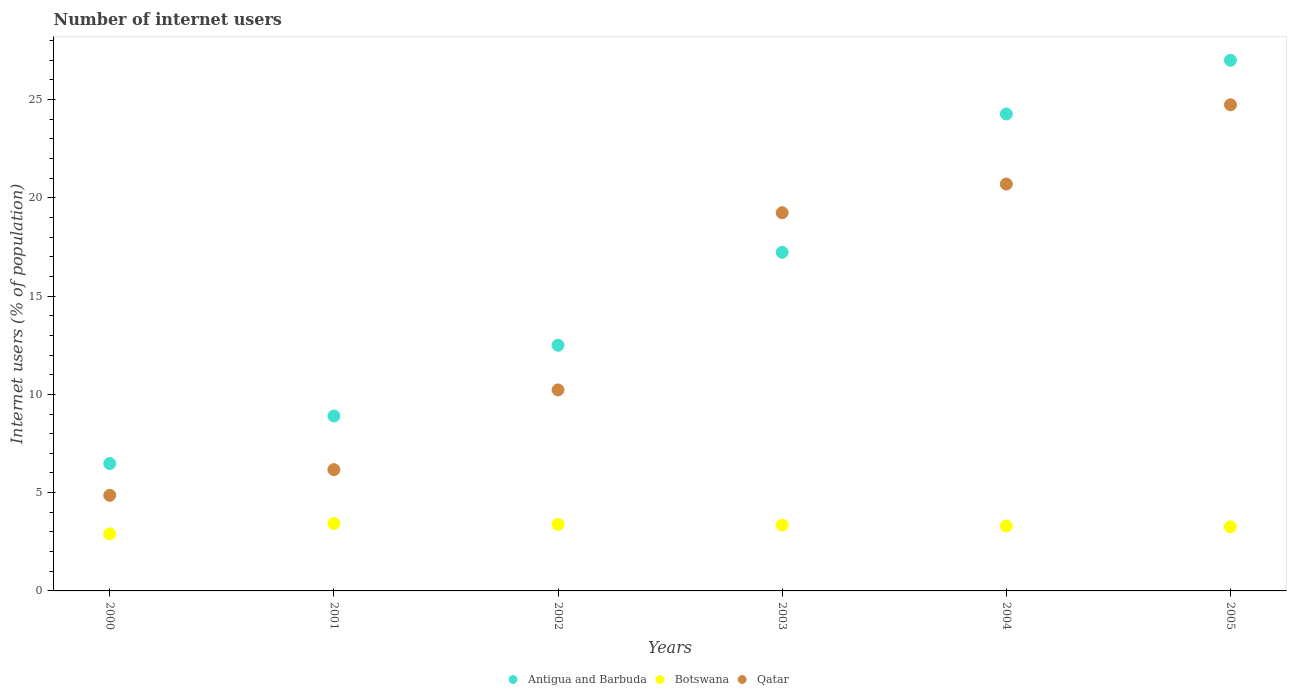How many different coloured dotlines are there?
Make the answer very short. 3. Is the number of dotlines equal to the number of legend labels?
Provide a succinct answer. Yes. What is the number of internet users in Botswana in 2005?
Offer a very short reply. 3.26. Across all years, what is the maximum number of internet users in Botswana?
Offer a very short reply. 3.43. Across all years, what is the minimum number of internet users in Qatar?
Your response must be concise. 4.86. What is the total number of internet users in Antigua and Barbuda in the graph?
Keep it short and to the point. 96.38. What is the difference between the number of internet users in Botswana in 2002 and that in 2004?
Your answer should be very brief. 0.08. What is the difference between the number of internet users in Botswana in 2002 and the number of internet users in Antigua and Barbuda in 2000?
Ensure brevity in your answer.  -3.1. What is the average number of internet users in Qatar per year?
Offer a very short reply. 14.32. In the year 2004, what is the difference between the number of internet users in Botswana and number of internet users in Antigua and Barbuda?
Ensure brevity in your answer.  -20.96. What is the ratio of the number of internet users in Botswana in 2002 to that in 2005?
Provide a succinct answer. 1.04. Is the number of internet users in Botswana in 2000 less than that in 2005?
Offer a very short reply. Yes. What is the difference between the highest and the second highest number of internet users in Antigua and Barbuda?
Your answer should be very brief. 2.73. What is the difference between the highest and the lowest number of internet users in Botswana?
Provide a succinct answer. 0.53. Is the sum of the number of internet users in Botswana in 2004 and 2005 greater than the maximum number of internet users in Antigua and Barbuda across all years?
Give a very brief answer. No. Does the number of internet users in Qatar monotonically increase over the years?
Provide a succinct answer. Yes. Is the number of internet users in Antigua and Barbuda strictly greater than the number of internet users in Botswana over the years?
Your answer should be very brief. Yes. Is the number of internet users in Antigua and Barbuda strictly less than the number of internet users in Botswana over the years?
Keep it short and to the point. No. What is the difference between two consecutive major ticks on the Y-axis?
Your answer should be compact. 5. Are the values on the major ticks of Y-axis written in scientific E-notation?
Your response must be concise. No. Does the graph contain any zero values?
Your answer should be compact. No. Where does the legend appear in the graph?
Offer a very short reply. Bottom center. How many legend labels are there?
Keep it short and to the point. 3. How are the legend labels stacked?
Ensure brevity in your answer.  Horizontal. What is the title of the graph?
Keep it short and to the point. Number of internet users. What is the label or title of the X-axis?
Give a very brief answer. Years. What is the label or title of the Y-axis?
Your answer should be very brief. Internet users (% of population). What is the Internet users (% of population) of Antigua and Barbuda in 2000?
Give a very brief answer. 6.48. What is the Internet users (% of population) of Botswana in 2000?
Offer a very short reply. 2.9. What is the Internet users (% of population) in Qatar in 2000?
Offer a terse response. 4.86. What is the Internet users (% of population) in Antigua and Barbuda in 2001?
Your answer should be very brief. 8.9. What is the Internet users (% of population) of Botswana in 2001?
Provide a short and direct response. 3.43. What is the Internet users (% of population) in Qatar in 2001?
Ensure brevity in your answer.  6.17. What is the Internet users (% of population) in Botswana in 2002?
Provide a succinct answer. 3.39. What is the Internet users (% of population) in Qatar in 2002?
Offer a terse response. 10.23. What is the Internet users (% of population) in Antigua and Barbuda in 2003?
Provide a short and direct response. 17.23. What is the Internet users (% of population) in Botswana in 2003?
Give a very brief answer. 3.35. What is the Internet users (% of population) of Qatar in 2003?
Make the answer very short. 19.24. What is the Internet users (% of population) of Antigua and Barbuda in 2004?
Provide a short and direct response. 24.27. What is the Internet users (% of population) of Botswana in 2004?
Provide a short and direct response. 3.3. What is the Internet users (% of population) in Qatar in 2004?
Your answer should be compact. 20.7. What is the Internet users (% of population) of Botswana in 2005?
Provide a short and direct response. 3.26. What is the Internet users (% of population) in Qatar in 2005?
Your answer should be compact. 24.73. Across all years, what is the maximum Internet users (% of population) of Botswana?
Your answer should be very brief. 3.43. Across all years, what is the maximum Internet users (% of population) in Qatar?
Your answer should be compact. 24.73. Across all years, what is the minimum Internet users (% of population) in Antigua and Barbuda?
Keep it short and to the point. 6.48. Across all years, what is the minimum Internet users (% of population) of Botswana?
Ensure brevity in your answer.  2.9. Across all years, what is the minimum Internet users (% of population) in Qatar?
Offer a very short reply. 4.86. What is the total Internet users (% of population) in Antigua and Barbuda in the graph?
Your response must be concise. 96.38. What is the total Internet users (% of population) of Botswana in the graph?
Offer a very short reply. 19.63. What is the total Internet users (% of population) in Qatar in the graph?
Your answer should be very brief. 85.94. What is the difference between the Internet users (% of population) in Antigua and Barbuda in 2000 and that in 2001?
Your answer should be compact. -2.42. What is the difference between the Internet users (% of population) of Botswana in 2000 and that in 2001?
Keep it short and to the point. -0.53. What is the difference between the Internet users (% of population) of Qatar in 2000 and that in 2001?
Provide a succinct answer. -1.31. What is the difference between the Internet users (% of population) in Antigua and Barbuda in 2000 and that in 2002?
Provide a short and direct response. -6.02. What is the difference between the Internet users (% of population) in Botswana in 2000 and that in 2002?
Your answer should be very brief. -0.48. What is the difference between the Internet users (% of population) of Qatar in 2000 and that in 2002?
Provide a succinct answer. -5.36. What is the difference between the Internet users (% of population) of Antigua and Barbuda in 2000 and that in 2003?
Make the answer very short. -10.75. What is the difference between the Internet users (% of population) of Botswana in 2000 and that in 2003?
Offer a very short reply. -0.44. What is the difference between the Internet users (% of population) of Qatar in 2000 and that in 2003?
Make the answer very short. -14.38. What is the difference between the Internet users (% of population) in Antigua and Barbuda in 2000 and that in 2004?
Make the answer very short. -17.78. What is the difference between the Internet users (% of population) in Botswana in 2000 and that in 2004?
Provide a short and direct response. -0.4. What is the difference between the Internet users (% of population) of Qatar in 2000 and that in 2004?
Your response must be concise. -15.84. What is the difference between the Internet users (% of population) in Antigua and Barbuda in 2000 and that in 2005?
Your answer should be compact. -20.52. What is the difference between the Internet users (% of population) of Botswana in 2000 and that in 2005?
Offer a very short reply. -0.36. What is the difference between the Internet users (% of population) in Qatar in 2000 and that in 2005?
Keep it short and to the point. -19.87. What is the difference between the Internet users (% of population) of Antigua and Barbuda in 2001 and that in 2002?
Provide a short and direct response. -3.6. What is the difference between the Internet users (% of population) of Botswana in 2001 and that in 2002?
Your answer should be very brief. 0.04. What is the difference between the Internet users (% of population) of Qatar in 2001 and that in 2002?
Make the answer very short. -4.06. What is the difference between the Internet users (% of population) in Antigua and Barbuda in 2001 and that in 2003?
Provide a succinct answer. -8.33. What is the difference between the Internet users (% of population) in Botswana in 2001 and that in 2003?
Provide a succinct answer. 0.09. What is the difference between the Internet users (% of population) of Qatar in 2001 and that in 2003?
Provide a succinct answer. -13.07. What is the difference between the Internet users (% of population) in Antigua and Barbuda in 2001 and that in 2004?
Provide a short and direct response. -15.37. What is the difference between the Internet users (% of population) in Botswana in 2001 and that in 2004?
Your answer should be compact. 0.13. What is the difference between the Internet users (% of population) in Qatar in 2001 and that in 2004?
Offer a terse response. -14.53. What is the difference between the Internet users (% of population) of Antigua and Barbuda in 2001 and that in 2005?
Your answer should be compact. -18.1. What is the difference between the Internet users (% of population) in Botswana in 2001 and that in 2005?
Provide a succinct answer. 0.17. What is the difference between the Internet users (% of population) in Qatar in 2001 and that in 2005?
Your response must be concise. -18.56. What is the difference between the Internet users (% of population) of Antigua and Barbuda in 2002 and that in 2003?
Your answer should be compact. -4.73. What is the difference between the Internet users (% of population) in Botswana in 2002 and that in 2003?
Your answer should be very brief. 0.04. What is the difference between the Internet users (% of population) of Qatar in 2002 and that in 2003?
Ensure brevity in your answer.  -9.02. What is the difference between the Internet users (% of population) of Antigua and Barbuda in 2002 and that in 2004?
Offer a very short reply. -11.77. What is the difference between the Internet users (% of population) in Botswana in 2002 and that in 2004?
Give a very brief answer. 0.08. What is the difference between the Internet users (% of population) in Qatar in 2002 and that in 2004?
Your answer should be very brief. -10.48. What is the difference between the Internet users (% of population) in Antigua and Barbuda in 2002 and that in 2005?
Your response must be concise. -14.5. What is the difference between the Internet users (% of population) of Botswana in 2002 and that in 2005?
Give a very brief answer. 0.12. What is the difference between the Internet users (% of population) of Qatar in 2002 and that in 2005?
Your answer should be very brief. -14.51. What is the difference between the Internet users (% of population) in Antigua and Barbuda in 2003 and that in 2004?
Provide a short and direct response. -7.04. What is the difference between the Internet users (% of population) in Botswana in 2003 and that in 2004?
Provide a succinct answer. 0.04. What is the difference between the Internet users (% of population) in Qatar in 2003 and that in 2004?
Your answer should be very brief. -1.46. What is the difference between the Internet users (% of population) of Antigua and Barbuda in 2003 and that in 2005?
Give a very brief answer. -9.77. What is the difference between the Internet users (% of population) of Botswana in 2003 and that in 2005?
Your answer should be very brief. 0.08. What is the difference between the Internet users (% of population) of Qatar in 2003 and that in 2005?
Give a very brief answer. -5.49. What is the difference between the Internet users (% of population) in Antigua and Barbuda in 2004 and that in 2005?
Your answer should be very brief. -2.73. What is the difference between the Internet users (% of population) of Botswana in 2004 and that in 2005?
Make the answer very short. 0.04. What is the difference between the Internet users (% of population) of Qatar in 2004 and that in 2005?
Give a very brief answer. -4.03. What is the difference between the Internet users (% of population) in Antigua and Barbuda in 2000 and the Internet users (% of population) in Botswana in 2001?
Your answer should be compact. 3.05. What is the difference between the Internet users (% of population) in Antigua and Barbuda in 2000 and the Internet users (% of population) in Qatar in 2001?
Your response must be concise. 0.31. What is the difference between the Internet users (% of population) in Botswana in 2000 and the Internet users (% of population) in Qatar in 2001?
Keep it short and to the point. -3.27. What is the difference between the Internet users (% of population) of Antigua and Barbuda in 2000 and the Internet users (% of population) of Botswana in 2002?
Your response must be concise. 3.1. What is the difference between the Internet users (% of population) in Antigua and Barbuda in 2000 and the Internet users (% of population) in Qatar in 2002?
Offer a very short reply. -3.74. What is the difference between the Internet users (% of population) of Botswana in 2000 and the Internet users (% of population) of Qatar in 2002?
Provide a short and direct response. -7.32. What is the difference between the Internet users (% of population) in Antigua and Barbuda in 2000 and the Internet users (% of population) in Botswana in 2003?
Your answer should be compact. 3.14. What is the difference between the Internet users (% of population) in Antigua and Barbuda in 2000 and the Internet users (% of population) in Qatar in 2003?
Keep it short and to the point. -12.76. What is the difference between the Internet users (% of population) in Botswana in 2000 and the Internet users (% of population) in Qatar in 2003?
Make the answer very short. -16.34. What is the difference between the Internet users (% of population) in Antigua and Barbuda in 2000 and the Internet users (% of population) in Botswana in 2004?
Offer a terse response. 3.18. What is the difference between the Internet users (% of population) in Antigua and Barbuda in 2000 and the Internet users (% of population) in Qatar in 2004?
Offer a terse response. -14.22. What is the difference between the Internet users (% of population) of Botswana in 2000 and the Internet users (% of population) of Qatar in 2004?
Provide a short and direct response. -17.8. What is the difference between the Internet users (% of population) of Antigua and Barbuda in 2000 and the Internet users (% of population) of Botswana in 2005?
Ensure brevity in your answer.  3.22. What is the difference between the Internet users (% of population) in Antigua and Barbuda in 2000 and the Internet users (% of population) in Qatar in 2005?
Provide a short and direct response. -18.25. What is the difference between the Internet users (% of population) in Botswana in 2000 and the Internet users (% of population) in Qatar in 2005?
Your answer should be compact. -21.83. What is the difference between the Internet users (% of population) in Antigua and Barbuda in 2001 and the Internet users (% of population) in Botswana in 2002?
Keep it short and to the point. 5.51. What is the difference between the Internet users (% of population) of Antigua and Barbuda in 2001 and the Internet users (% of population) of Qatar in 2002?
Give a very brief answer. -1.33. What is the difference between the Internet users (% of population) of Botswana in 2001 and the Internet users (% of population) of Qatar in 2002?
Provide a short and direct response. -6.8. What is the difference between the Internet users (% of population) of Antigua and Barbuda in 2001 and the Internet users (% of population) of Botswana in 2003?
Give a very brief answer. 5.55. What is the difference between the Internet users (% of population) of Antigua and Barbuda in 2001 and the Internet users (% of population) of Qatar in 2003?
Your answer should be compact. -10.34. What is the difference between the Internet users (% of population) of Botswana in 2001 and the Internet users (% of population) of Qatar in 2003?
Offer a terse response. -15.81. What is the difference between the Internet users (% of population) in Antigua and Barbuda in 2001 and the Internet users (% of population) in Botswana in 2004?
Your answer should be very brief. 5.59. What is the difference between the Internet users (% of population) of Antigua and Barbuda in 2001 and the Internet users (% of population) of Qatar in 2004?
Your answer should be compact. -11.8. What is the difference between the Internet users (% of population) of Botswana in 2001 and the Internet users (% of population) of Qatar in 2004?
Give a very brief answer. -17.27. What is the difference between the Internet users (% of population) in Antigua and Barbuda in 2001 and the Internet users (% of population) in Botswana in 2005?
Provide a succinct answer. 5.64. What is the difference between the Internet users (% of population) of Antigua and Barbuda in 2001 and the Internet users (% of population) of Qatar in 2005?
Your response must be concise. -15.83. What is the difference between the Internet users (% of population) of Botswana in 2001 and the Internet users (% of population) of Qatar in 2005?
Keep it short and to the point. -21.3. What is the difference between the Internet users (% of population) of Antigua and Barbuda in 2002 and the Internet users (% of population) of Botswana in 2003?
Your response must be concise. 9.15. What is the difference between the Internet users (% of population) in Antigua and Barbuda in 2002 and the Internet users (% of population) in Qatar in 2003?
Give a very brief answer. -6.74. What is the difference between the Internet users (% of population) in Botswana in 2002 and the Internet users (% of population) in Qatar in 2003?
Your answer should be compact. -15.86. What is the difference between the Internet users (% of population) in Antigua and Barbuda in 2002 and the Internet users (% of population) in Botswana in 2004?
Give a very brief answer. 9.2. What is the difference between the Internet users (% of population) of Antigua and Barbuda in 2002 and the Internet users (% of population) of Qatar in 2004?
Offer a terse response. -8.2. What is the difference between the Internet users (% of population) in Botswana in 2002 and the Internet users (% of population) in Qatar in 2004?
Provide a short and direct response. -17.32. What is the difference between the Internet users (% of population) of Antigua and Barbuda in 2002 and the Internet users (% of population) of Botswana in 2005?
Keep it short and to the point. 9.24. What is the difference between the Internet users (% of population) in Antigua and Barbuda in 2002 and the Internet users (% of population) in Qatar in 2005?
Make the answer very short. -12.23. What is the difference between the Internet users (% of population) in Botswana in 2002 and the Internet users (% of population) in Qatar in 2005?
Offer a very short reply. -21.35. What is the difference between the Internet users (% of population) in Antigua and Barbuda in 2003 and the Internet users (% of population) in Botswana in 2004?
Keep it short and to the point. 13.92. What is the difference between the Internet users (% of population) in Antigua and Barbuda in 2003 and the Internet users (% of population) in Qatar in 2004?
Give a very brief answer. -3.47. What is the difference between the Internet users (% of population) of Botswana in 2003 and the Internet users (% of population) of Qatar in 2004?
Provide a succinct answer. -17.36. What is the difference between the Internet users (% of population) of Antigua and Barbuda in 2003 and the Internet users (% of population) of Botswana in 2005?
Make the answer very short. 13.97. What is the difference between the Internet users (% of population) of Antigua and Barbuda in 2003 and the Internet users (% of population) of Qatar in 2005?
Provide a succinct answer. -7.5. What is the difference between the Internet users (% of population) in Botswana in 2003 and the Internet users (% of population) in Qatar in 2005?
Offer a terse response. -21.39. What is the difference between the Internet users (% of population) of Antigua and Barbuda in 2004 and the Internet users (% of population) of Botswana in 2005?
Give a very brief answer. 21. What is the difference between the Internet users (% of population) of Antigua and Barbuda in 2004 and the Internet users (% of population) of Qatar in 2005?
Your answer should be compact. -0.47. What is the difference between the Internet users (% of population) of Botswana in 2004 and the Internet users (% of population) of Qatar in 2005?
Provide a succinct answer. -21.43. What is the average Internet users (% of population) of Antigua and Barbuda per year?
Offer a very short reply. 16.06. What is the average Internet users (% of population) of Botswana per year?
Ensure brevity in your answer.  3.27. What is the average Internet users (% of population) in Qatar per year?
Your response must be concise. 14.32. In the year 2000, what is the difference between the Internet users (% of population) of Antigua and Barbuda and Internet users (% of population) of Botswana?
Offer a very short reply. 3.58. In the year 2000, what is the difference between the Internet users (% of population) in Antigua and Barbuda and Internet users (% of population) in Qatar?
Provide a succinct answer. 1.62. In the year 2000, what is the difference between the Internet users (% of population) of Botswana and Internet users (% of population) of Qatar?
Offer a terse response. -1.96. In the year 2001, what is the difference between the Internet users (% of population) in Antigua and Barbuda and Internet users (% of population) in Botswana?
Keep it short and to the point. 5.47. In the year 2001, what is the difference between the Internet users (% of population) of Antigua and Barbuda and Internet users (% of population) of Qatar?
Offer a terse response. 2.73. In the year 2001, what is the difference between the Internet users (% of population) in Botswana and Internet users (% of population) in Qatar?
Ensure brevity in your answer.  -2.74. In the year 2002, what is the difference between the Internet users (% of population) of Antigua and Barbuda and Internet users (% of population) of Botswana?
Your answer should be very brief. 9.11. In the year 2002, what is the difference between the Internet users (% of population) in Antigua and Barbuda and Internet users (% of population) in Qatar?
Keep it short and to the point. 2.27. In the year 2002, what is the difference between the Internet users (% of population) in Botswana and Internet users (% of population) in Qatar?
Your answer should be very brief. -6.84. In the year 2003, what is the difference between the Internet users (% of population) of Antigua and Barbuda and Internet users (% of population) of Botswana?
Provide a succinct answer. 13.88. In the year 2003, what is the difference between the Internet users (% of population) in Antigua and Barbuda and Internet users (% of population) in Qatar?
Make the answer very short. -2.01. In the year 2003, what is the difference between the Internet users (% of population) in Botswana and Internet users (% of population) in Qatar?
Offer a very short reply. -15.9. In the year 2004, what is the difference between the Internet users (% of population) of Antigua and Barbuda and Internet users (% of population) of Botswana?
Give a very brief answer. 20.96. In the year 2004, what is the difference between the Internet users (% of population) in Antigua and Barbuda and Internet users (% of population) in Qatar?
Your answer should be very brief. 3.56. In the year 2004, what is the difference between the Internet users (% of population) of Botswana and Internet users (% of population) of Qatar?
Give a very brief answer. -17.4. In the year 2005, what is the difference between the Internet users (% of population) in Antigua and Barbuda and Internet users (% of population) in Botswana?
Make the answer very short. 23.74. In the year 2005, what is the difference between the Internet users (% of population) in Antigua and Barbuda and Internet users (% of population) in Qatar?
Provide a short and direct response. 2.27. In the year 2005, what is the difference between the Internet users (% of population) of Botswana and Internet users (% of population) of Qatar?
Ensure brevity in your answer.  -21.47. What is the ratio of the Internet users (% of population) of Antigua and Barbuda in 2000 to that in 2001?
Give a very brief answer. 0.73. What is the ratio of the Internet users (% of population) of Botswana in 2000 to that in 2001?
Provide a succinct answer. 0.85. What is the ratio of the Internet users (% of population) of Qatar in 2000 to that in 2001?
Ensure brevity in your answer.  0.79. What is the ratio of the Internet users (% of population) of Antigua and Barbuda in 2000 to that in 2002?
Keep it short and to the point. 0.52. What is the ratio of the Internet users (% of population) in Botswana in 2000 to that in 2002?
Provide a succinct answer. 0.86. What is the ratio of the Internet users (% of population) in Qatar in 2000 to that in 2002?
Your answer should be very brief. 0.48. What is the ratio of the Internet users (% of population) in Antigua and Barbuda in 2000 to that in 2003?
Your response must be concise. 0.38. What is the ratio of the Internet users (% of population) of Botswana in 2000 to that in 2003?
Provide a short and direct response. 0.87. What is the ratio of the Internet users (% of population) of Qatar in 2000 to that in 2003?
Provide a succinct answer. 0.25. What is the ratio of the Internet users (% of population) in Antigua and Barbuda in 2000 to that in 2004?
Keep it short and to the point. 0.27. What is the ratio of the Internet users (% of population) of Botswana in 2000 to that in 2004?
Keep it short and to the point. 0.88. What is the ratio of the Internet users (% of population) in Qatar in 2000 to that in 2004?
Make the answer very short. 0.23. What is the ratio of the Internet users (% of population) in Antigua and Barbuda in 2000 to that in 2005?
Give a very brief answer. 0.24. What is the ratio of the Internet users (% of population) in Botswana in 2000 to that in 2005?
Offer a terse response. 0.89. What is the ratio of the Internet users (% of population) in Qatar in 2000 to that in 2005?
Your response must be concise. 0.2. What is the ratio of the Internet users (% of population) of Antigua and Barbuda in 2001 to that in 2002?
Provide a short and direct response. 0.71. What is the ratio of the Internet users (% of population) in Botswana in 2001 to that in 2002?
Provide a succinct answer. 1.01. What is the ratio of the Internet users (% of population) of Qatar in 2001 to that in 2002?
Keep it short and to the point. 0.6. What is the ratio of the Internet users (% of population) in Antigua and Barbuda in 2001 to that in 2003?
Give a very brief answer. 0.52. What is the ratio of the Internet users (% of population) in Botswana in 2001 to that in 2003?
Your response must be concise. 1.03. What is the ratio of the Internet users (% of population) of Qatar in 2001 to that in 2003?
Keep it short and to the point. 0.32. What is the ratio of the Internet users (% of population) of Antigua and Barbuda in 2001 to that in 2004?
Keep it short and to the point. 0.37. What is the ratio of the Internet users (% of population) of Botswana in 2001 to that in 2004?
Provide a short and direct response. 1.04. What is the ratio of the Internet users (% of population) in Qatar in 2001 to that in 2004?
Make the answer very short. 0.3. What is the ratio of the Internet users (% of population) in Antigua and Barbuda in 2001 to that in 2005?
Your answer should be very brief. 0.33. What is the ratio of the Internet users (% of population) in Botswana in 2001 to that in 2005?
Give a very brief answer. 1.05. What is the ratio of the Internet users (% of population) in Qatar in 2001 to that in 2005?
Keep it short and to the point. 0.25. What is the ratio of the Internet users (% of population) in Antigua and Barbuda in 2002 to that in 2003?
Your answer should be compact. 0.73. What is the ratio of the Internet users (% of population) of Botswana in 2002 to that in 2003?
Your answer should be very brief. 1.01. What is the ratio of the Internet users (% of population) of Qatar in 2002 to that in 2003?
Keep it short and to the point. 0.53. What is the ratio of the Internet users (% of population) in Antigua and Barbuda in 2002 to that in 2004?
Keep it short and to the point. 0.52. What is the ratio of the Internet users (% of population) in Botswana in 2002 to that in 2004?
Offer a very short reply. 1.02. What is the ratio of the Internet users (% of population) of Qatar in 2002 to that in 2004?
Ensure brevity in your answer.  0.49. What is the ratio of the Internet users (% of population) in Antigua and Barbuda in 2002 to that in 2005?
Your answer should be compact. 0.46. What is the ratio of the Internet users (% of population) in Botswana in 2002 to that in 2005?
Keep it short and to the point. 1.04. What is the ratio of the Internet users (% of population) in Qatar in 2002 to that in 2005?
Provide a succinct answer. 0.41. What is the ratio of the Internet users (% of population) in Antigua and Barbuda in 2003 to that in 2004?
Offer a very short reply. 0.71. What is the ratio of the Internet users (% of population) in Botswana in 2003 to that in 2004?
Your answer should be very brief. 1.01. What is the ratio of the Internet users (% of population) in Qatar in 2003 to that in 2004?
Give a very brief answer. 0.93. What is the ratio of the Internet users (% of population) of Antigua and Barbuda in 2003 to that in 2005?
Your answer should be compact. 0.64. What is the ratio of the Internet users (% of population) of Botswana in 2003 to that in 2005?
Make the answer very short. 1.03. What is the ratio of the Internet users (% of population) in Qatar in 2003 to that in 2005?
Your response must be concise. 0.78. What is the ratio of the Internet users (% of population) of Antigua and Barbuda in 2004 to that in 2005?
Offer a very short reply. 0.9. What is the ratio of the Internet users (% of population) in Qatar in 2004 to that in 2005?
Give a very brief answer. 0.84. What is the difference between the highest and the second highest Internet users (% of population) in Antigua and Barbuda?
Give a very brief answer. 2.73. What is the difference between the highest and the second highest Internet users (% of population) in Botswana?
Offer a terse response. 0.04. What is the difference between the highest and the second highest Internet users (% of population) of Qatar?
Your response must be concise. 4.03. What is the difference between the highest and the lowest Internet users (% of population) of Antigua and Barbuda?
Your answer should be compact. 20.52. What is the difference between the highest and the lowest Internet users (% of population) in Botswana?
Give a very brief answer. 0.53. What is the difference between the highest and the lowest Internet users (% of population) in Qatar?
Offer a very short reply. 19.87. 